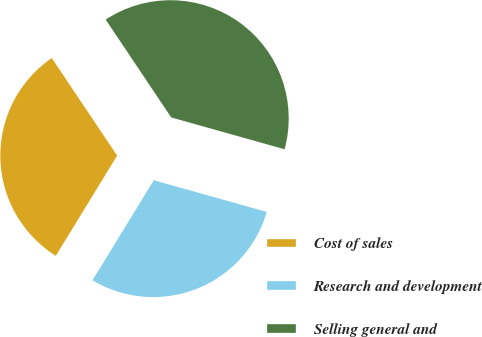Convert chart to OTSL. <chart><loc_0><loc_0><loc_500><loc_500><pie_chart><fcel>Cost of sales<fcel>Research and development<fcel>Selling general and<nl><fcel>31.86%<fcel>29.39%<fcel>38.75%<nl></chart> 